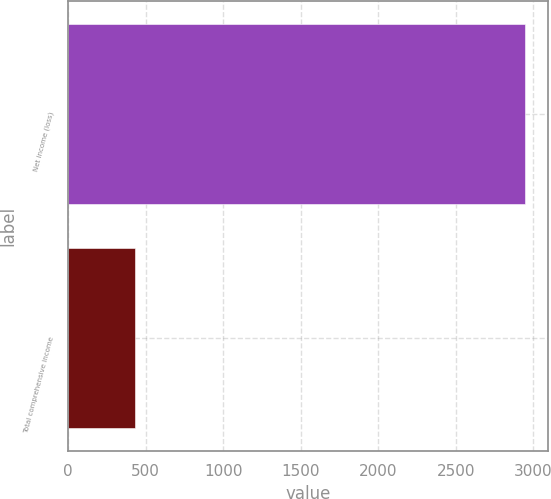<chart> <loc_0><loc_0><loc_500><loc_500><bar_chart><fcel>Net income (loss)<fcel>Total comprehensive income<nl><fcel>2948<fcel>432<nl></chart> 